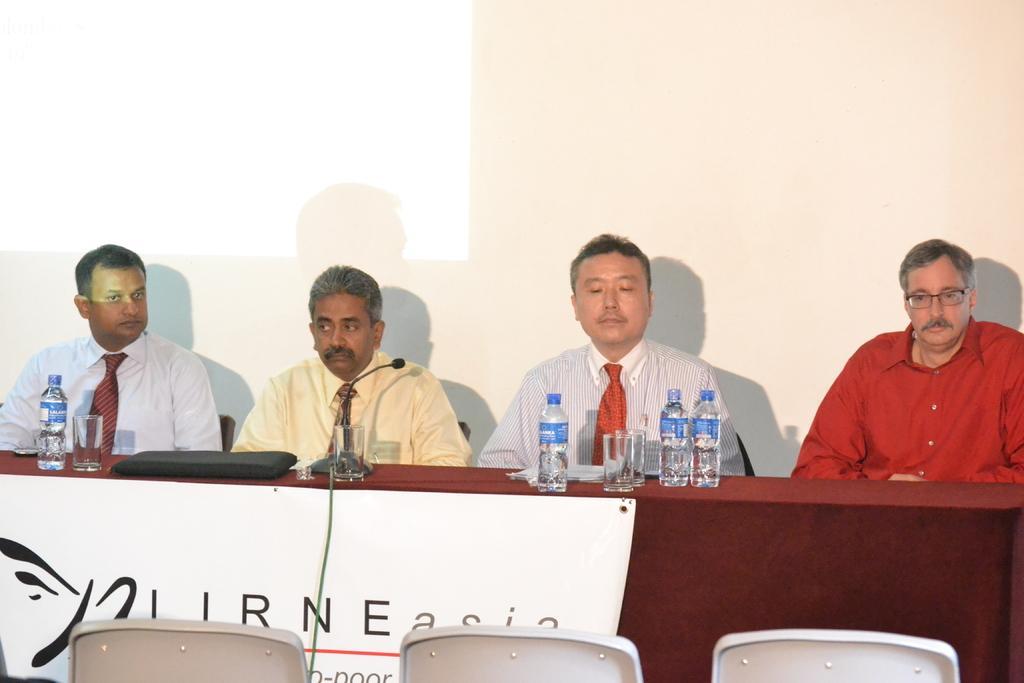How would you summarize this image in a sentence or two? In this image I can see four men who are sitting on the chair in front of the table. On the table we have a couple of water bottles and glasses. On the table we also have a microphone and few other objects on it. In front of the people we have 3 empty chairs and behind these people we have a projector screen. 